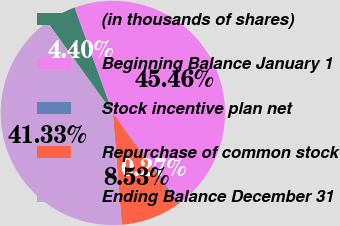Convert chart. <chart><loc_0><loc_0><loc_500><loc_500><pie_chart><fcel>(in thousands of shares)<fcel>Beginning Balance January 1<fcel>Stock incentive plan net<fcel>Repurchase of common stock<fcel>Ending Balance December 31<nl><fcel>4.4%<fcel>45.46%<fcel>0.27%<fcel>8.53%<fcel>41.33%<nl></chart> 